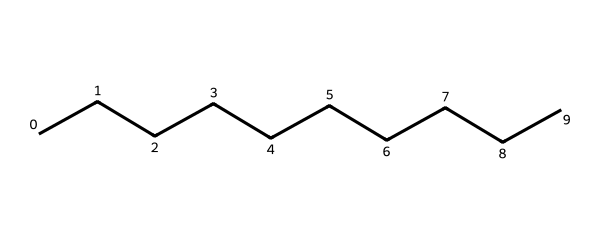What is the total number of carbon atoms in this hydrocarbon? The SMILES representation shows a linear structure with ten 'C' symbols, indicating there are ten carbon atoms.
Answer: ten What type of hydrocarbon is represented in this structure? The structure consists only of carbon and hydrogen in a straightforward linear arrangement, which classifies it as an alkane.
Answer: alkane How many hydrogen atoms are present in this hydrocarbon? In a saturated hydrocarbon (alkane), the number of hydrogen atoms can be calculated using the formulaCnH2n+2. Here, n equals ten, so the number of hydrogen atoms is 2(10) + 2 = 22.
Answer: twenty-two What is the longest continuous carbon chain in this hydrocarbon? The SMILES representation shows that all ten carbon atoms are arranged in a straight chain without branching, meaning the longest continuous carbon chain is ten carbons long.
Answer: ten How many single bonds are present in this hydrocarbon structure? In this saturated alkane with ten carbon atoms, each carbon atom is bonded to two hydrogen atoms and has two single bonds with adjacent carbon atoms, totaling nine single bonds connecting the ten carbon atoms.
Answer: nine What is the general formula of the hydrocarbon represented? The structure is an alkane with n as the number of carbon atoms, leading to the general formula CnH2n+2. Since there are ten carbon atoms, the general formula is C10H22.
Answer: CnH2n+2 What physical state can this hydrocarbon exist at room temperature? Given that the structure is an alkane with a relatively long carbon chain, compounds like this typically exist as a liquid at room temperature due to their larger molecular weight.
Answer: liquid 